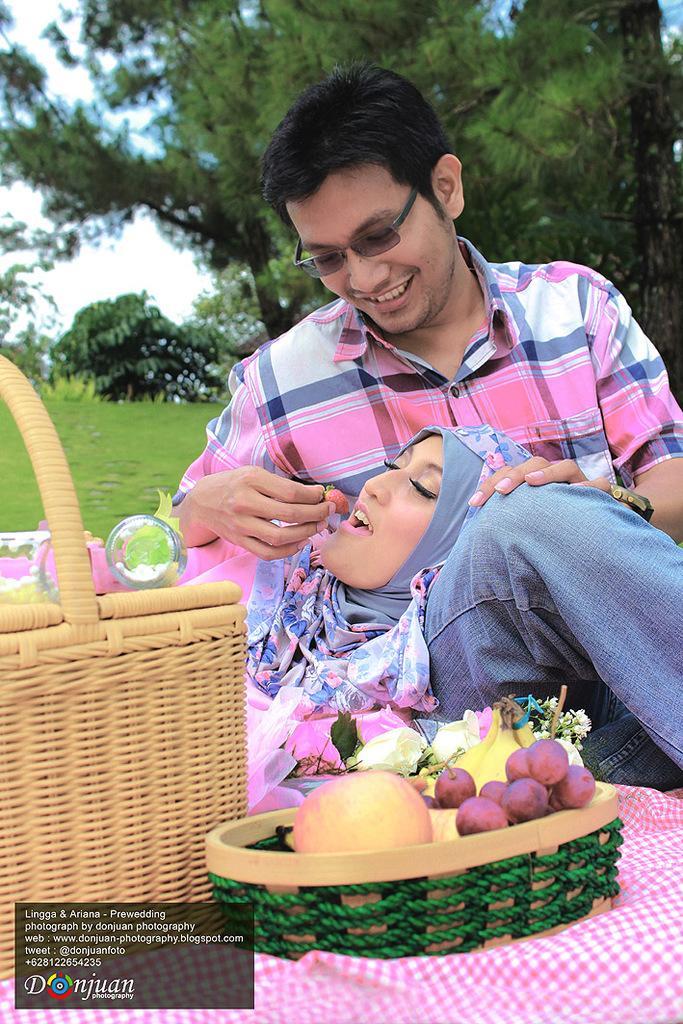Can you describe this image briefly? This woman is lying on this person lap. This man is smiling, looking at this woman and holding a fruit. On this cloth there are baskets. In this basket there are fruits. Here we can see flowers. These are bottles. Background we can see trees, grass and sky. Left side bottom of the image there is a watermark. 